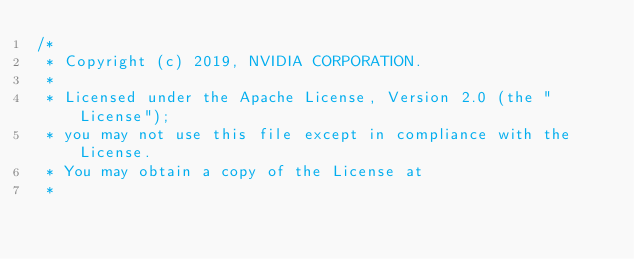Convert code to text. <code><loc_0><loc_0><loc_500><loc_500><_Cuda_>/*
 * Copyright (c) 2019, NVIDIA CORPORATION.
 *
 * Licensed under the Apache License, Version 2.0 (the "License");
 * you may not use this file except in compliance with the License.
 * You may obtain a copy of the License at
 *</code> 